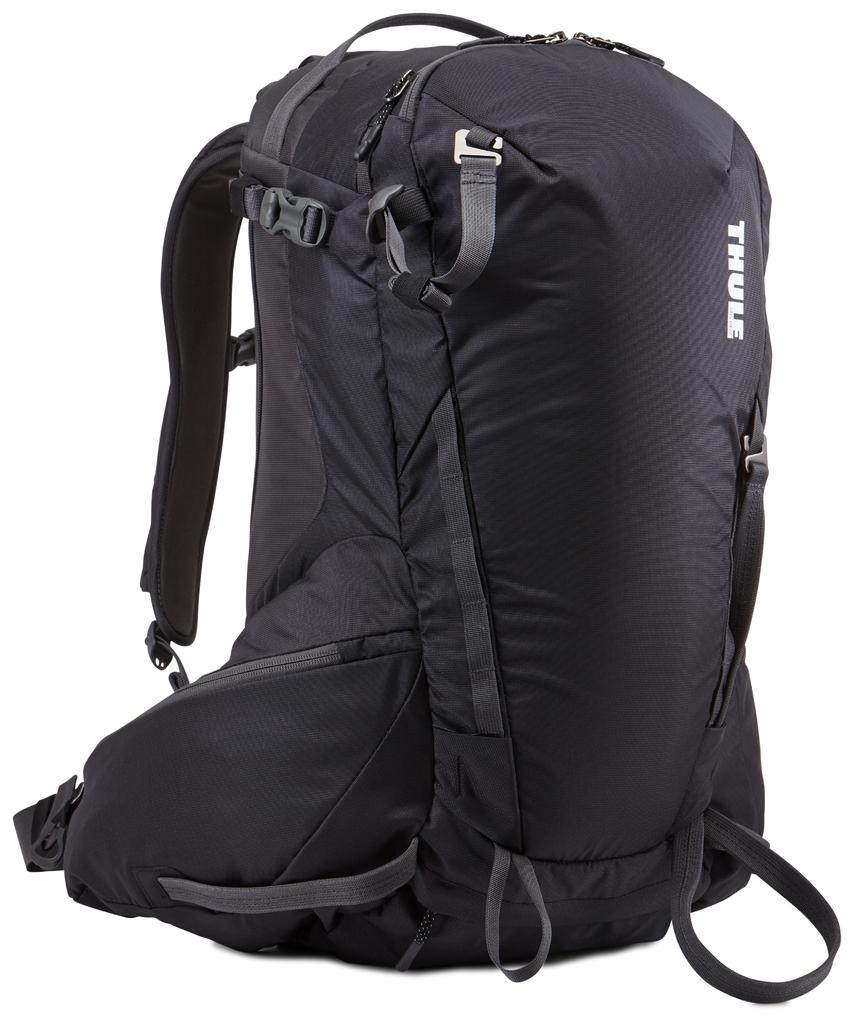<image>
Give a short and clear explanation of the subsequent image. A black Thule backpack that contains many straps and fasteners. 